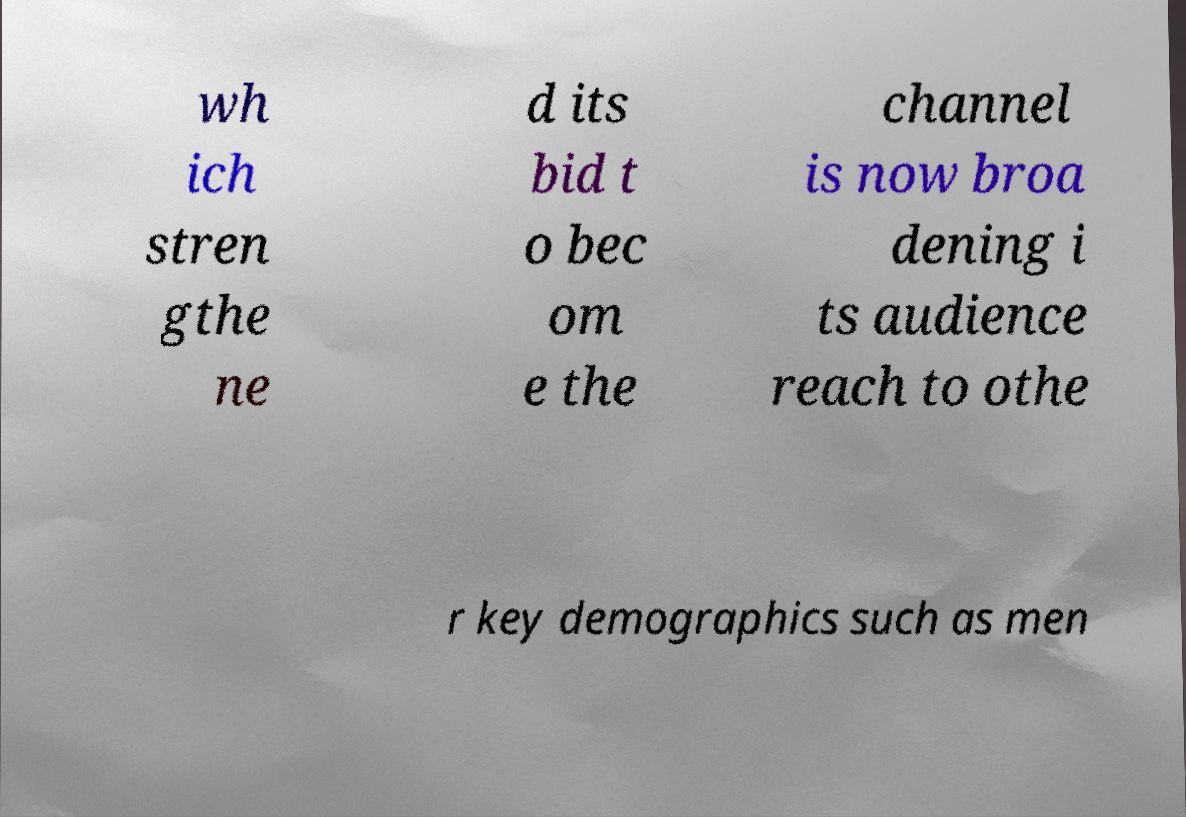Can you accurately transcribe the text from the provided image for me? wh ich stren gthe ne d its bid t o bec om e the channel is now broa dening i ts audience reach to othe r key demographics such as men 